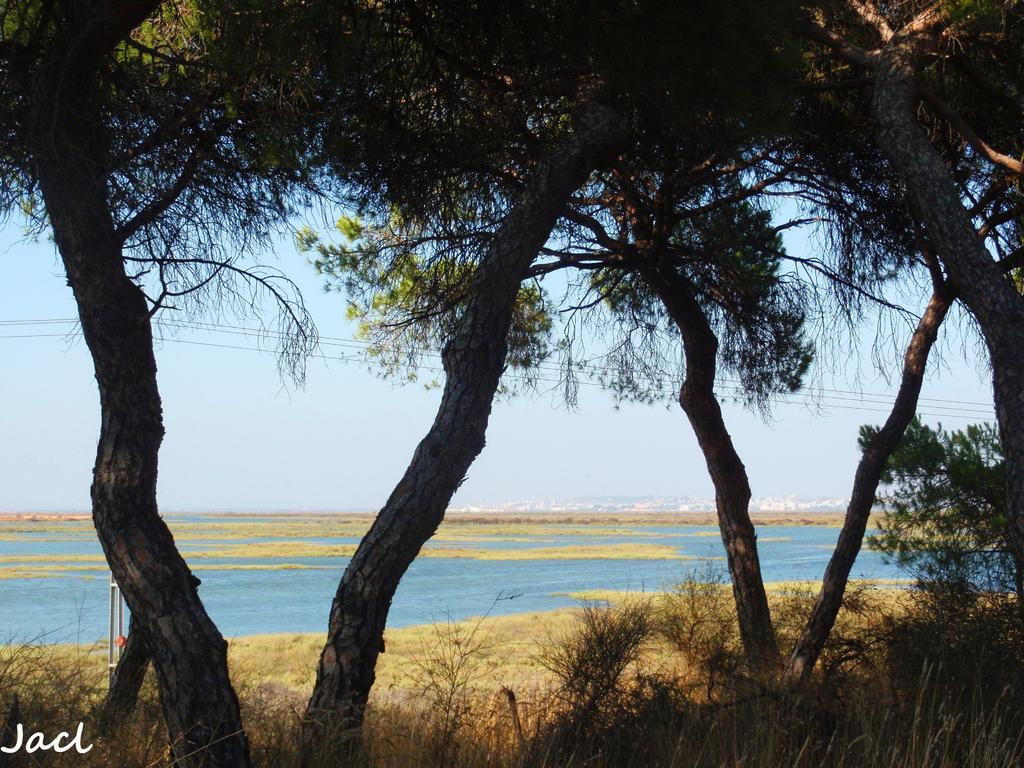In one or two sentences, can you explain what this image depicts? In this picture there is grassland at the bottom side of the image and there are trees at the top side of the image and there is water in the background area of the image. 